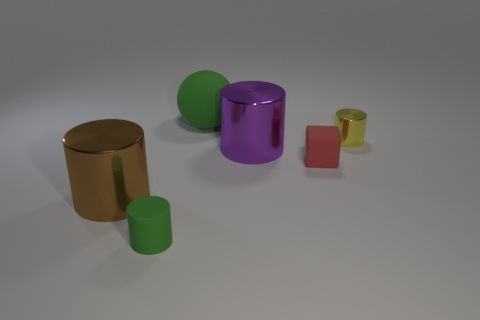Do the green matte thing in front of the large matte object and the green object behind the cube have the same shape?
Offer a very short reply. No. Is the color of the cube the same as the metallic thing right of the small red rubber cube?
Offer a terse response. No. There is a big shiny thing that is behind the large brown object; is its color the same as the rubber block?
Your answer should be compact. No. What number of things are either tiny rubber things or green objects that are on the right side of the small green matte cylinder?
Offer a terse response. 3. There is a thing that is both behind the small matte cylinder and in front of the small red thing; what is its material?
Offer a terse response. Metal. What is the large thing in front of the red cube made of?
Your answer should be very brief. Metal. What is the color of the sphere that is made of the same material as the red object?
Ensure brevity in your answer.  Green. There is a big green thing; does it have the same shape as the green object in front of the tiny yellow cylinder?
Provide a succinct answer. No. Are there any small cylinders behind the purple metallic thing?
Your answer should be very brief. Yes. There is a big thing that is the same color as the tiny matte cylinder; what is its material?
Your answer should be very brief. Rubber. 